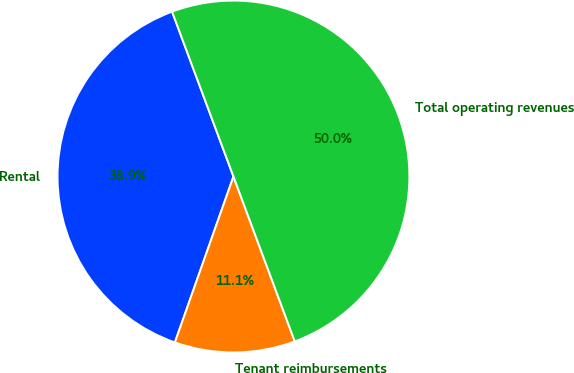Convert chart. <chart><loc_0><loc_0><loc_500><loc_500><pie_chart><fcel>Rental<fcel>Tenant reimbursements<fcel>Total operating revenues<nl><fcel>38.93%<fcel>11.07%<fcel>50.01%<nl></chart> 